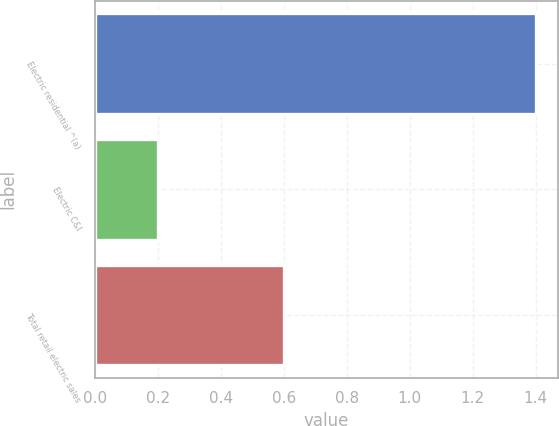<chart> <loc_0><loc_0><loc_500><loc_500><bar_chart><fcel>Electric residential ^(a)<fcel>Electric C&I<fcel>Total retail electric sales<nl><fcel>1.4<fcel>0.2<fcel>0.6<nl></chart> 